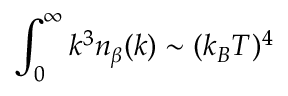<formula> <loc_0><loc_0><loc_500><loc_500>\int _ { 0 } ^ { \infty } k ^ { 3 } n _ { \beta } ( k ) \sim ( k _ { B } T ) ^ { 4 }</formula> 